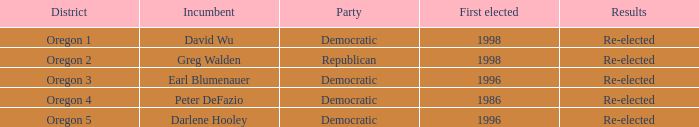Who is the present office holder for the oregon 5 district that was elected in 1996? Darlene Hooley. 